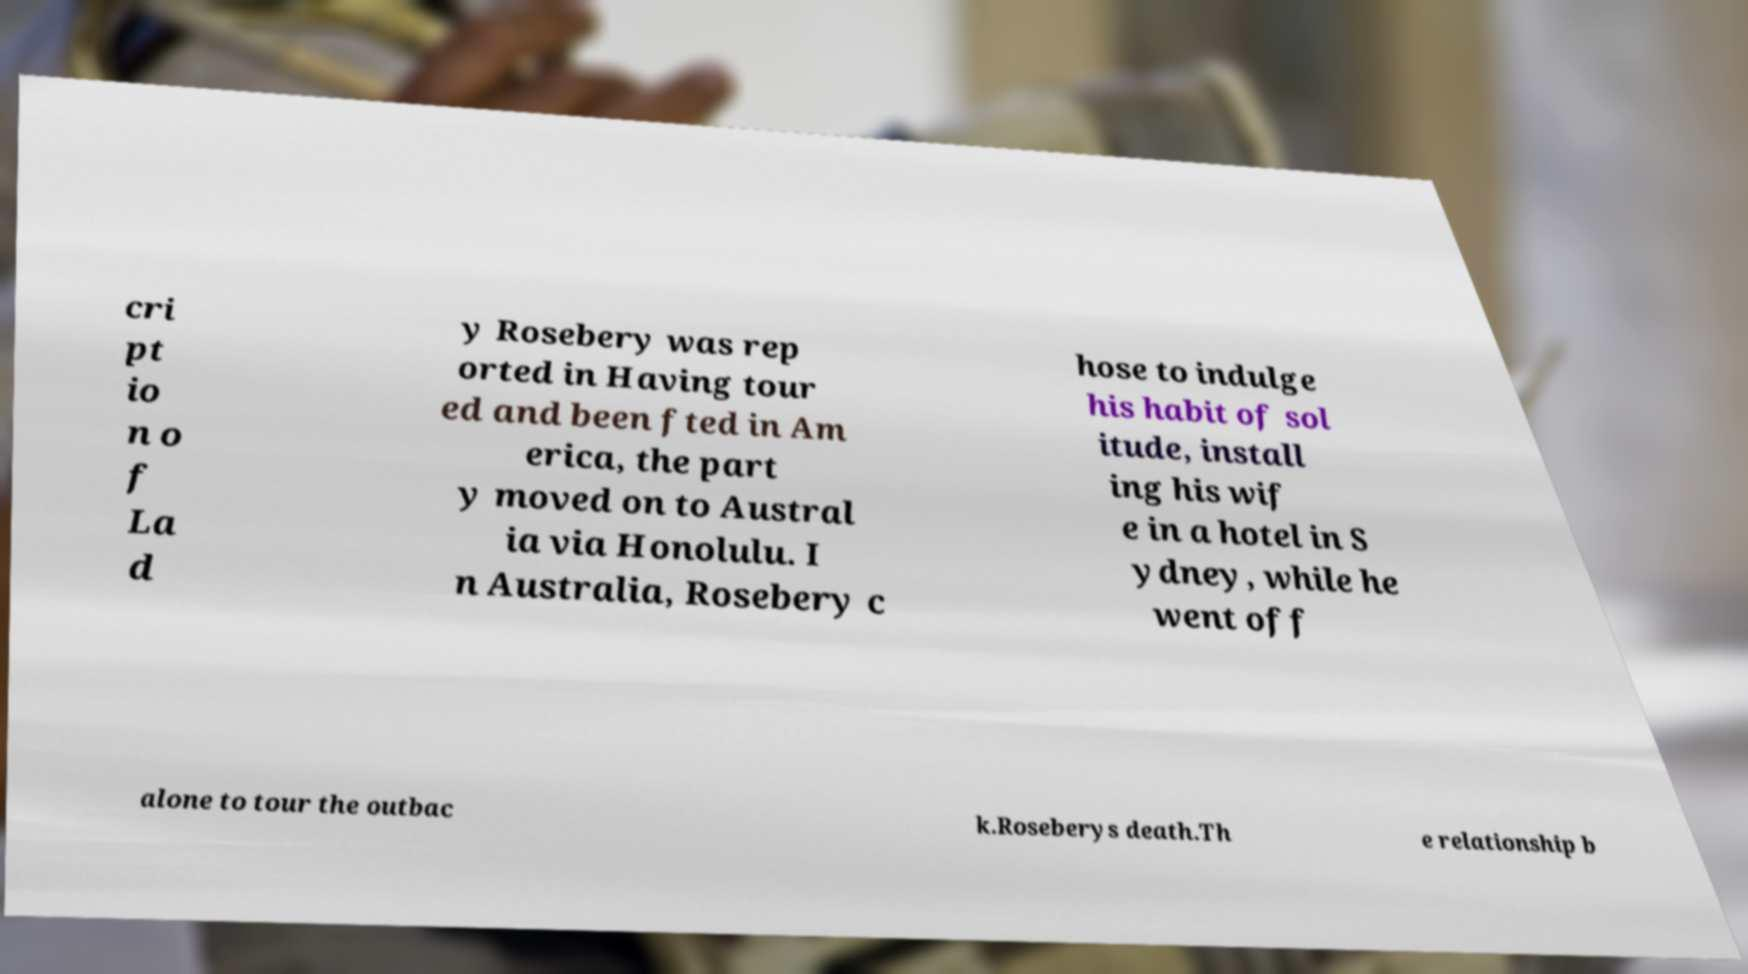What messages or text are displayed in this image? I need them in a readable, typed format. cri pt io n o f La d y Rosebery was rep orted in Having tour ed and been fted in Am erica, the part y moved on to Austral ia via Honolulu. I n Australia, Rosebery c hose to indulge his habit of sol itude, install ing his wif e in a hotel in S ydney, while he went off alone to tour the outbac k.Roseberys death.Th e relationship b 